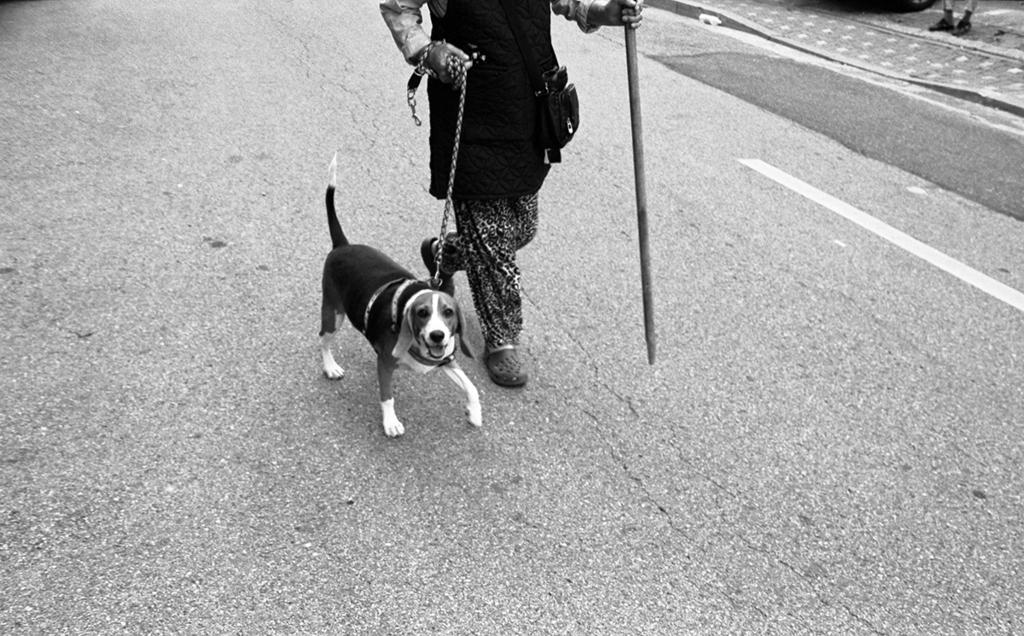Who or what is walking alongside the person in the image? There is a dog in the image, and the person and the dog are walking. What is the person holding in the image? The person is holding a stick and a chain. How is the dog connected to the person? The dog has a strap on its neck, which may be connected to the chain held by the person. What type of coach can be seen in the image? There is no coach present in the image; it features a person walking with a dog. How does the dog roll in the image? The dog does not roll in the image; it is walking alongside the person. 